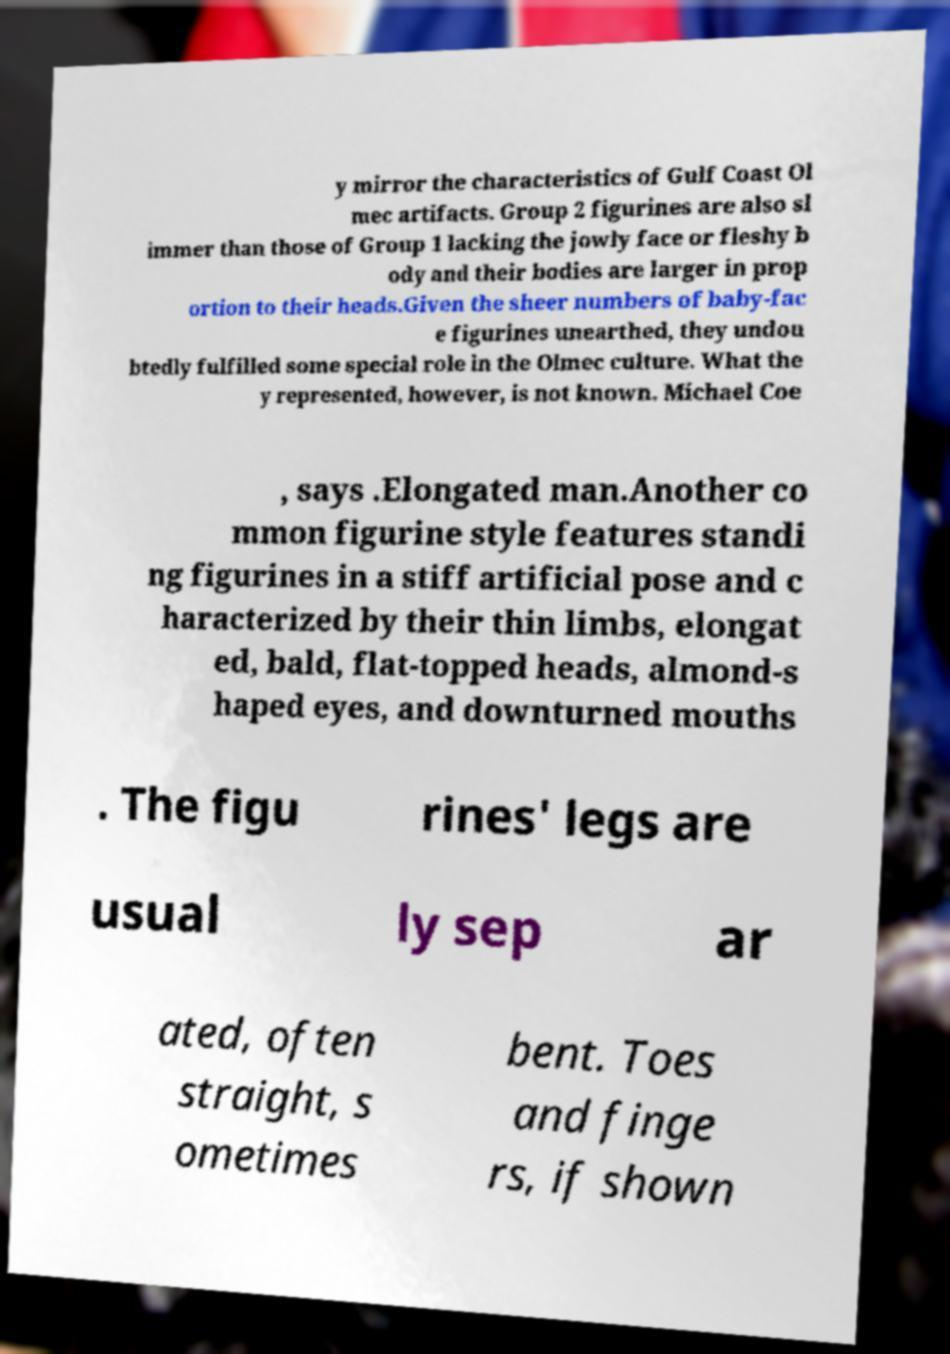Can you read and provide the text displayed in the image?This photo seems to have some interesting text. Can you extract and type it out for me? y mirror the characteristics of Gulf Coast Ol mec artifacts. Group 2 figurines are also sl immer than those of Group 1 lacking the jowly face or fleshy b ody and their bodies are larger in prop ortion to their heads.Given the sheer numbers of baby-fac e figurines unearthed, they undou btedly fulfilled some special role in the Olmec culture. What the y represented, however, is not known. Michael Coe , says .Elongated man.Another co mmon figurine style features standi ng figurines in a stiff artificial pose and c haracterized by their thin limbs, elongat ed, bald, flat-topped heads, almond-s haped eyes, and downturned mouths . The figu rines' legs are usual ly sep ar ated, often straight, s ometimes bent. Toes and finge rs, if shown 